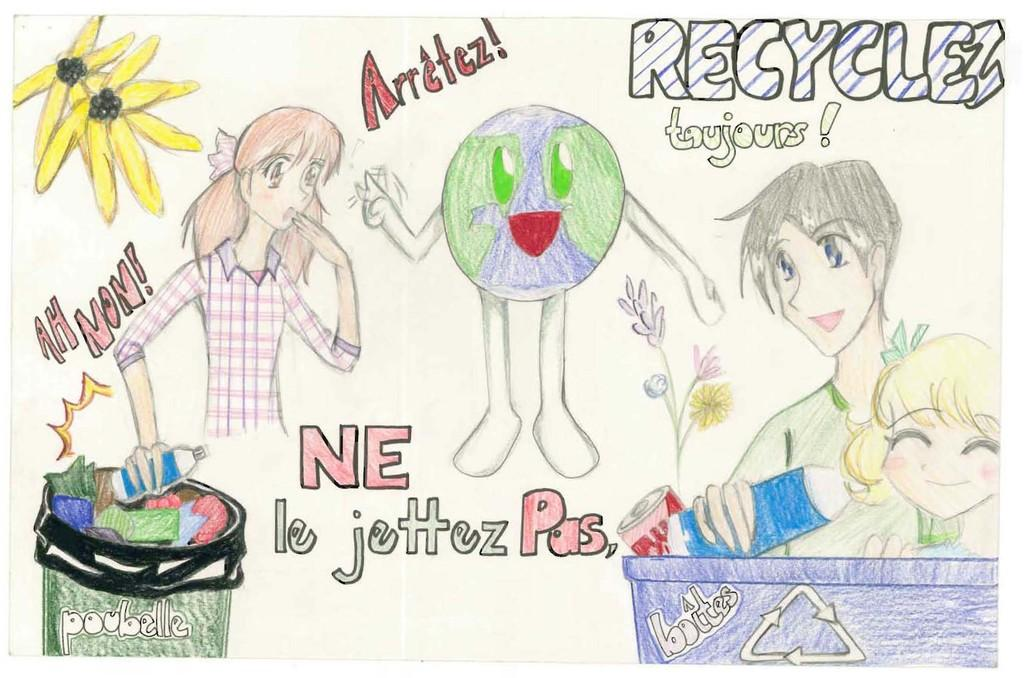What is depicted in the image? The image contains a drawing of people. What are the people in the drawing doing? A: The people in the drawing are holding bottles. Are there any other elements in the drawing besides the people and bottles? Yes, there are flowers and a trash bin in the drawing. Reasoning: Let' Let's think step by step in order to produce the conversation. We start by identifying the main subject of the image, which is a drawing of people. Then, we describe what the people are doing in the drawing, which is holding bottles. Finally, we mention the other elements present in the drawing, such as flowers and a trash bin. Absurd Question/Answer: What type of property is visible in the drawing? There is no property visible in the drawing; it features a drawing of people holding bottles, flowers, and a trash bin. Which direction is the north in the drawing? The concept of direction, such as north, is not applicable to a drawing, as it is a two-dimensional representation. What type of pain is being experienced by the people in the drawing? There is no indication of pain being experienced by the people in the drawing; they are simply holding bottles. 